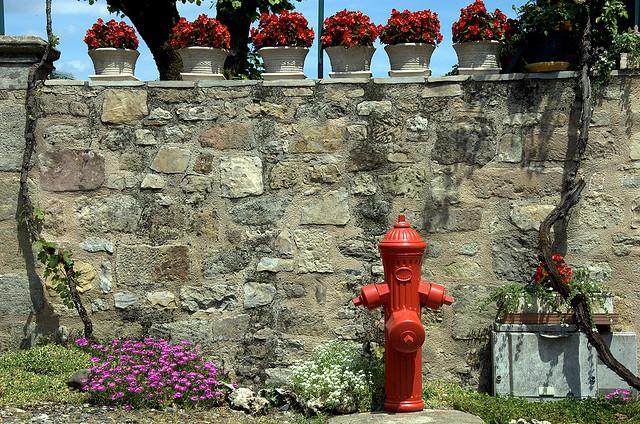How many pots are filled with red flowers?
Keep it brief. 6. What color is the hydrant?
Be succinct. Red. Where are the flower pots that hold flowers?
Be succinct. On wall. 